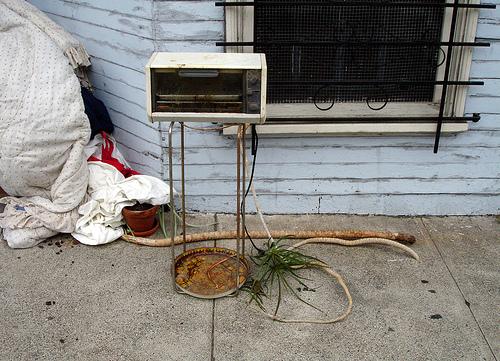Does the appliance on the stand appear to be in working condition?
Write a very short answer. No. What kind of appliance is on the stand?
Keep it brief. Toaster oven. Are the items considered junk?
Concise answer only. Yes. 